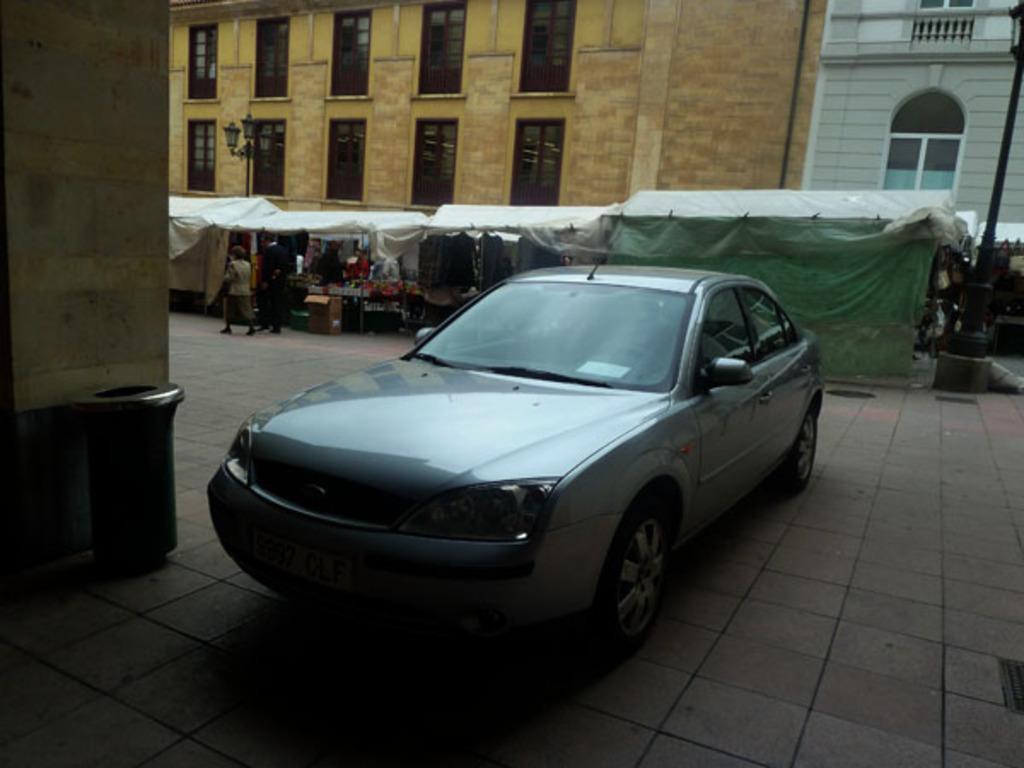Could you give a brief overview of what you see in this image? In this image I can see a car and a trash can just beside the car. I can see some stalls in the center of the image with some people. At the top of the image I can see some buildings. 